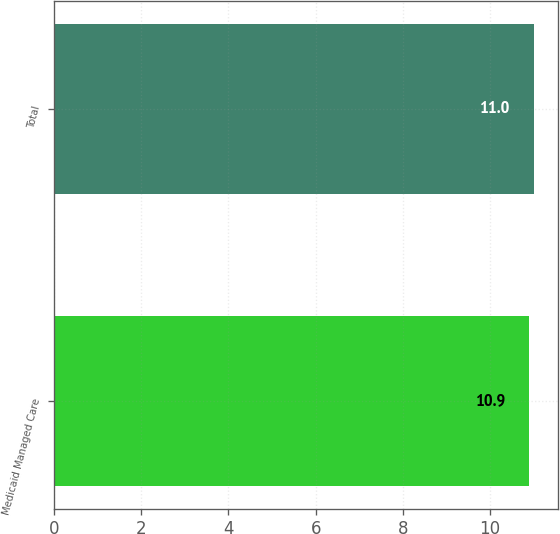Convert chart to OTSL. <chart><loc_0><loc_0><loc_500><loc_500><bar_chart><fcel>Medicaid Managed Care<fcel>Total<nl><fcel>10.9<fcel>11<nl></chart> 